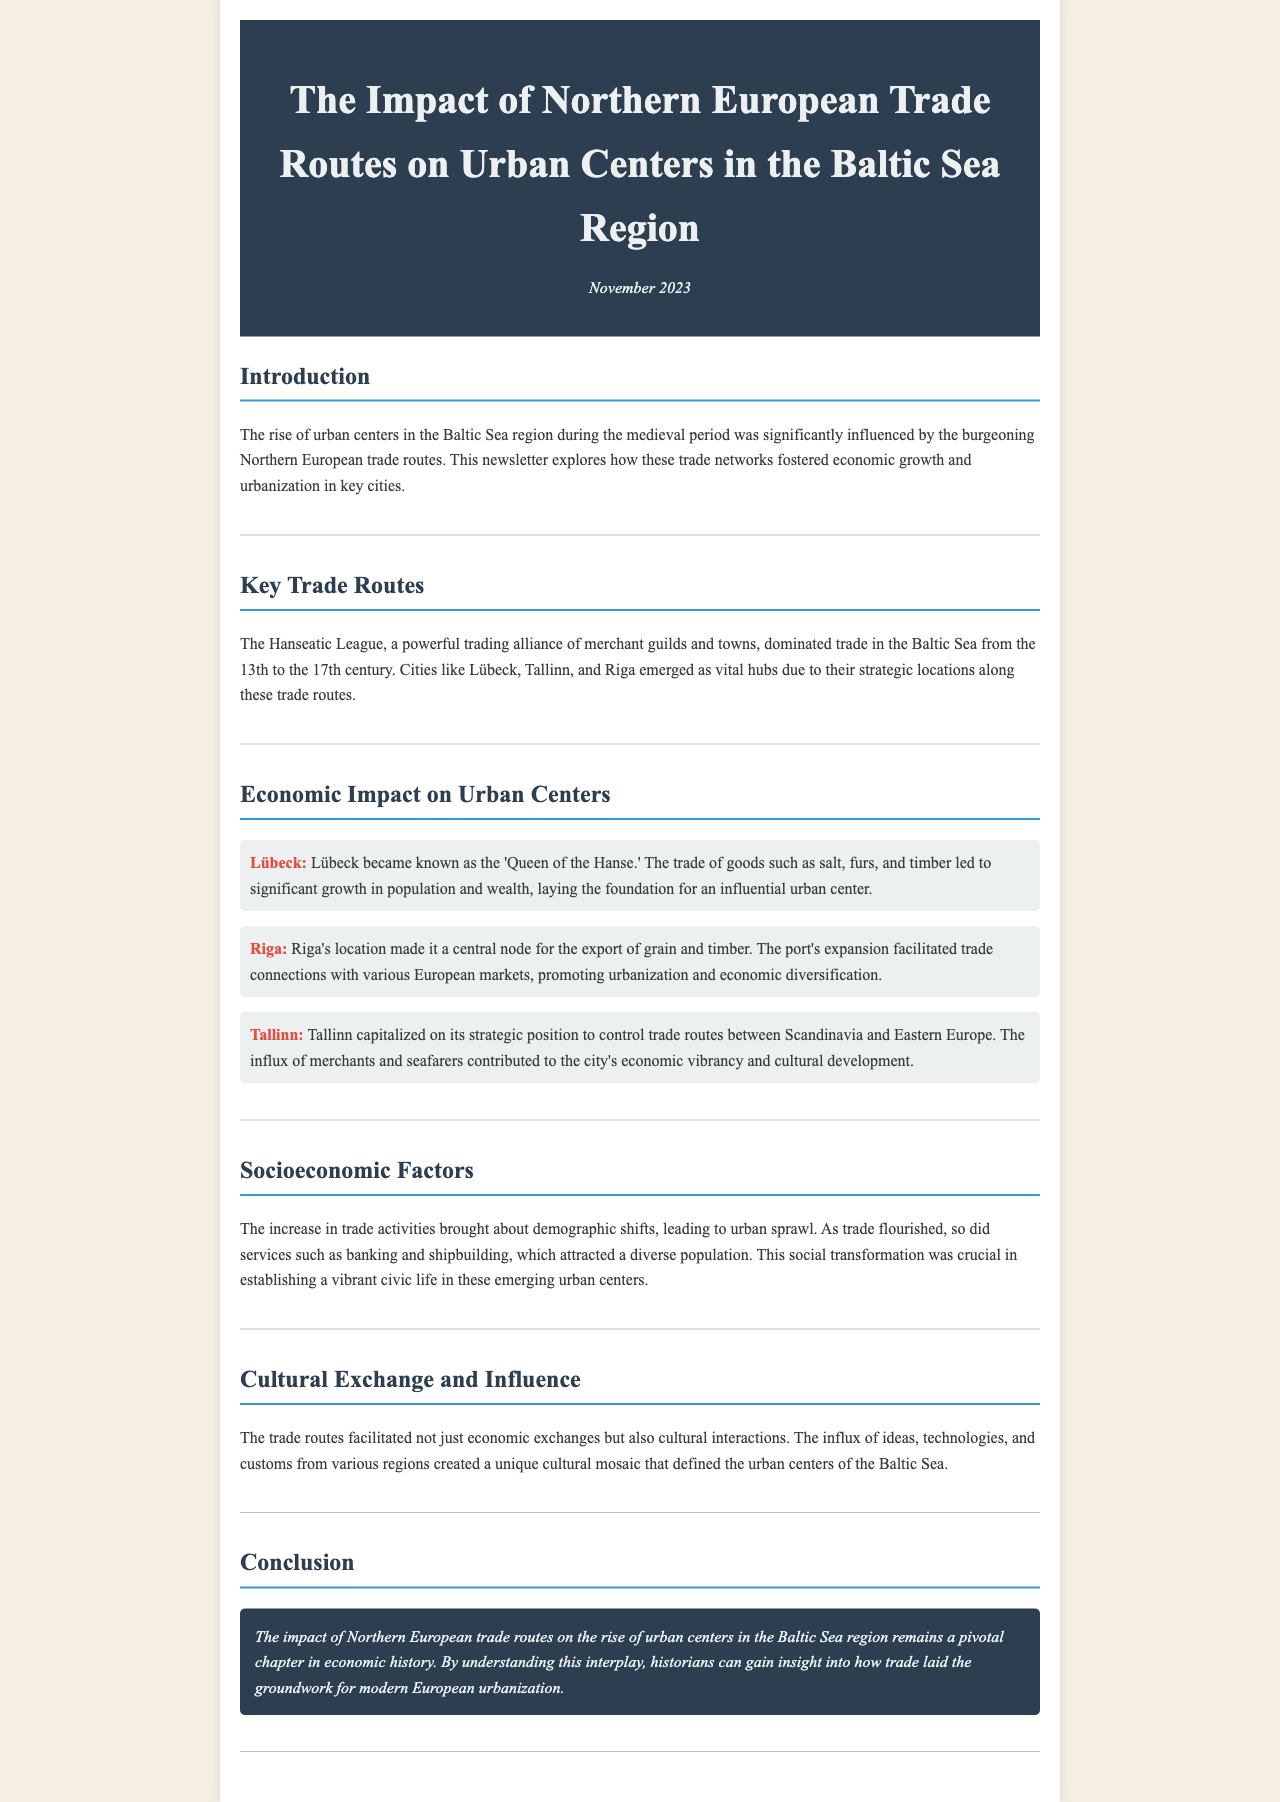What was the primary trade alliance mentioned? The document states that the Hanseatic League was the dominant trade alliance during this period.
Answer: Hanseatic League Which city is referred to as the 'Queen of the Hanse'? The document indicates that Lübeck earned this title due to its significance in trade.
Answer: Lübeck What type of goods contributed to Lübeck's economic growth? Goods such as salt, furs, and timber are mentioned as key contributors to Lübeck's growth.
Answer: salt, furs, and timber What was Riga known for exporting? The document mentions that Riga was a central node for the export of grain and timber.
Answer: grain and timber How did trade impact demographic shifts in urban centers? The document explains that increased trade activities led to urban sprawl and attracted a diverse population.
Answer: urban sprawl What cultural aspect did trade routes facilitate besides economic exchanges? The document states that trade routes facilitated cultural interactions, encompassing ideas, technologies, and customs.
Answer: cultural interactions During which centuries did the Hanseatic League dominate trade? The document specifies the 13th to the 17th century as the period of the Hanseatic League's dominance.
Answer: 13th to 17th century What major factor contributed to Tallinn's economic vibrancy? The influx of merchants and seafarers is highlighted as a major contributor to Tallinn's economic growth.
Answer: influx of merchants and seafarers What is the overall conclusion about the impact of Northern European trade routes? The conclusion underscores that these trade routes played a crucial role in the rise of urban centers.
Answer: crucial role 